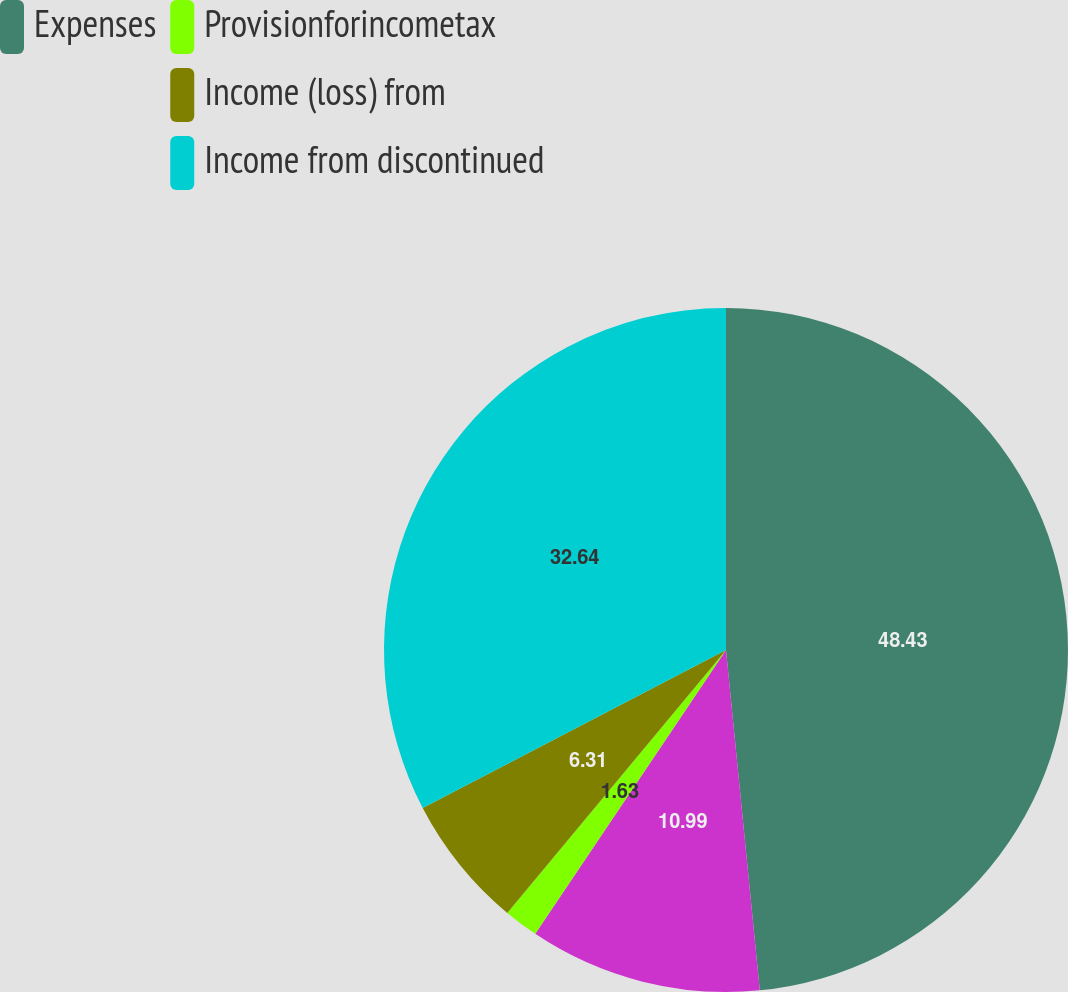Convert chart to OTSL. <chart><loc_0><loc_0><loc_500><loc_500><pie_chart><fcel>Expenses<fcel>Unnamed: 1<fcel>Provisionforincometax<fcel>Income (loss) from<fcel>Income from discontinued<nl><fcel>48.42%<fcel>10.99%<fcel>1.63%<fcel>6.31%<fcel>32.64%<nl></chart> 